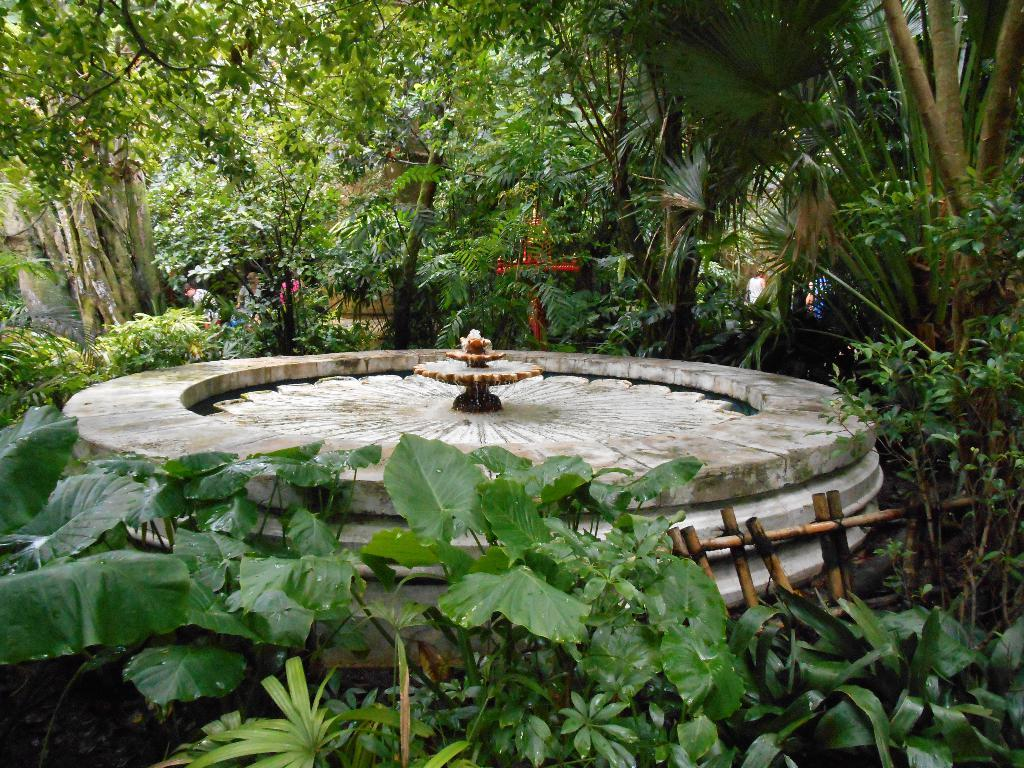What is the main feature in the image? There is a fountain in the image. Where is the fountain situated? The fountain is located between trees. What can be seen near the fountain? There is a wooden fence near the fountain. What is visible in the background of the image? There are people and a wall visible in the background of the image. How does the fountain contribute to the tax revenue in the image? The image does not provide any information about tax revenue, so it cannot be determined how the fountain contributes to it. 